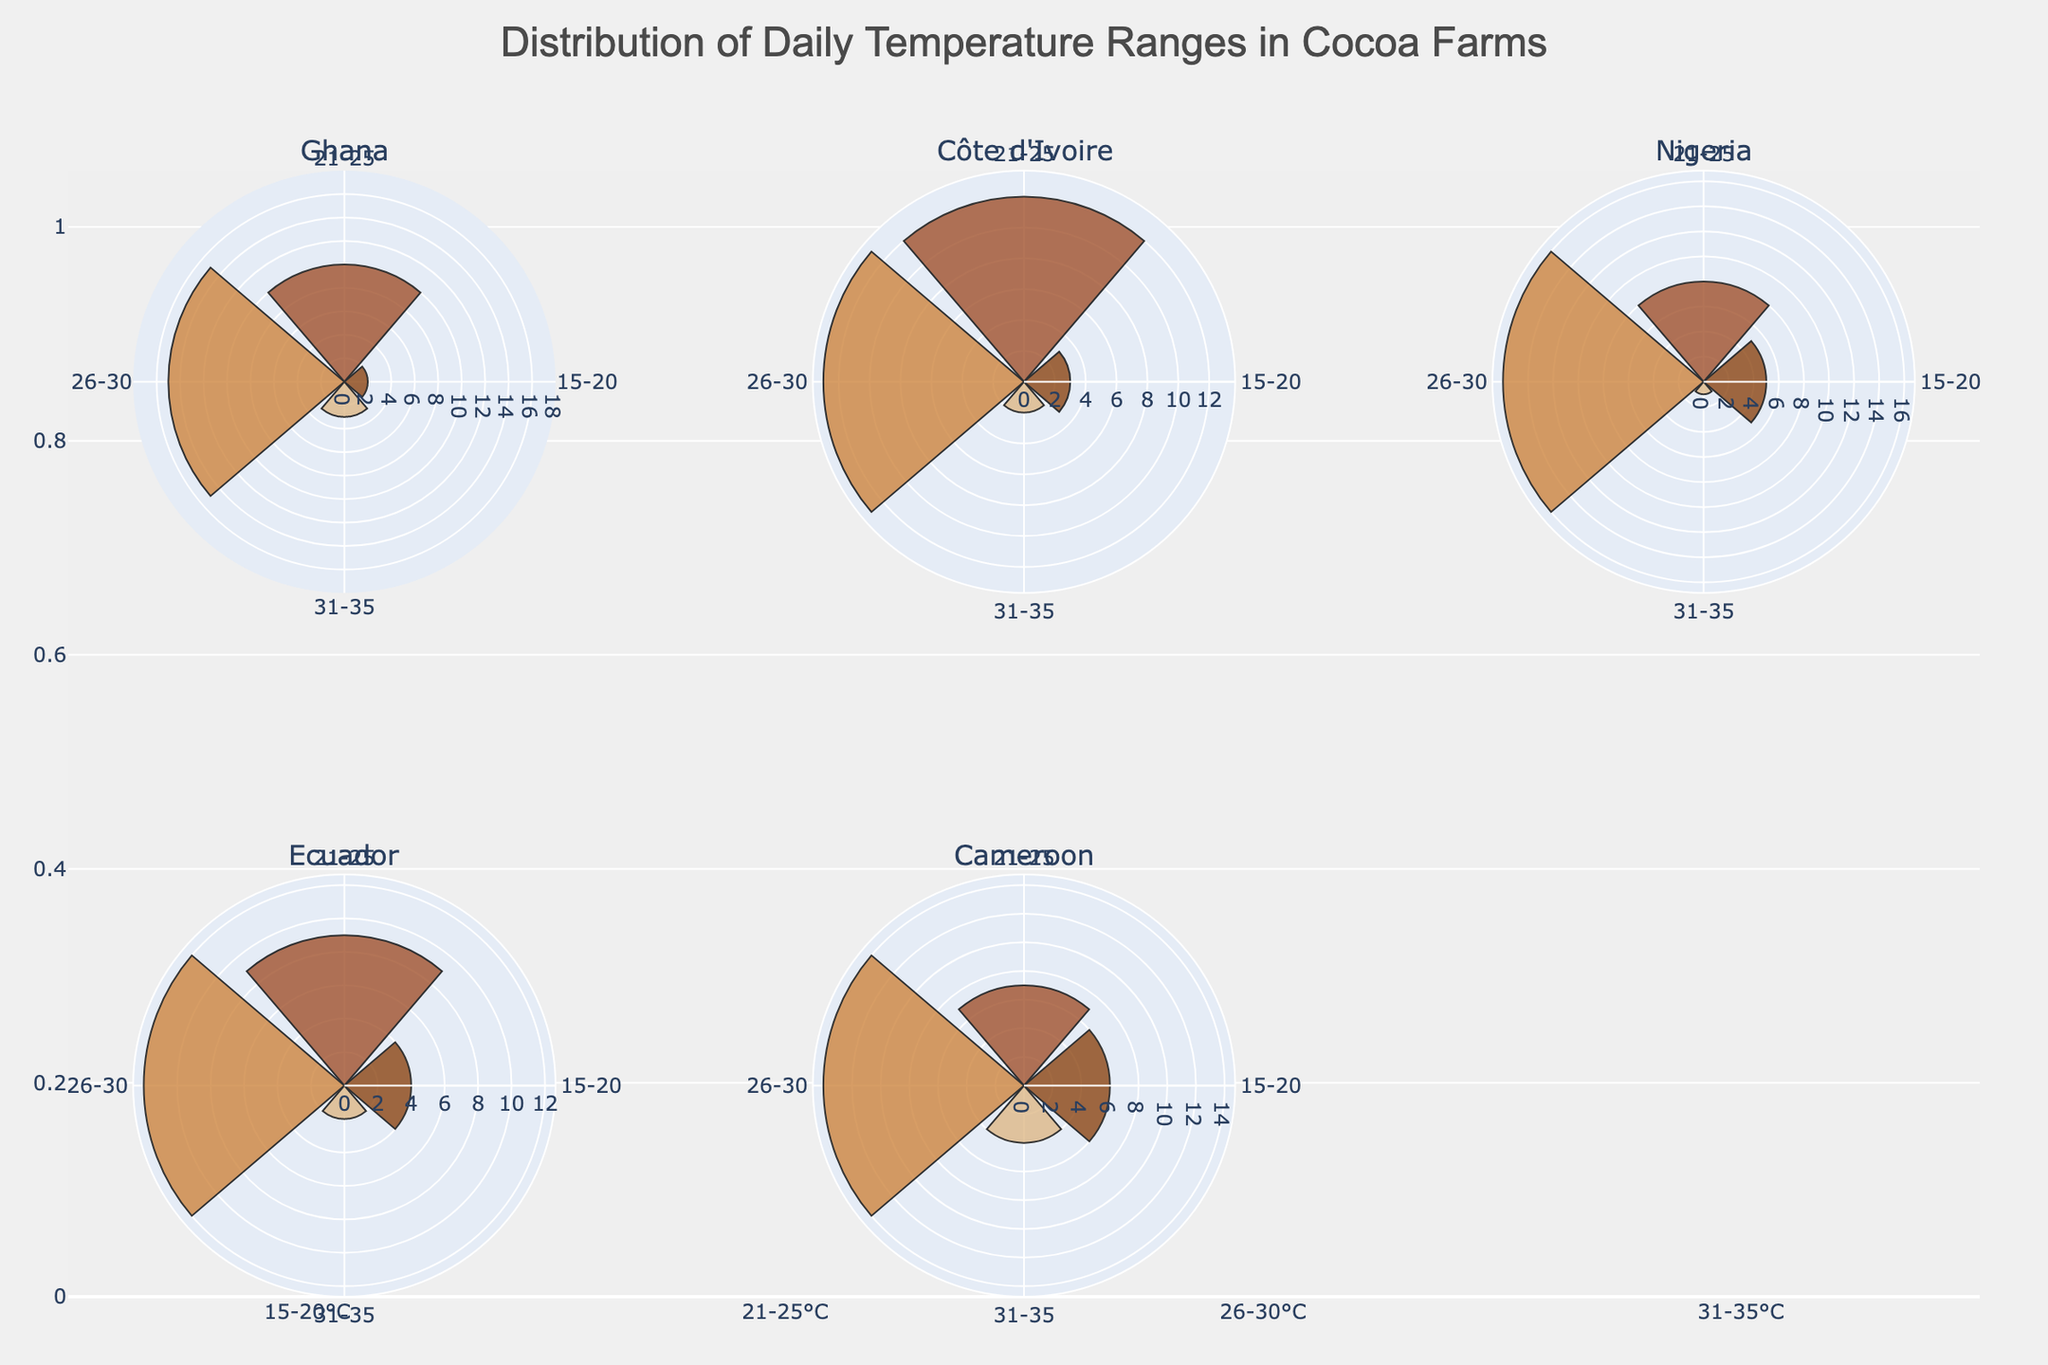What's the title of the plot? The title is located at the top center of the figure. It describes the overall content of the plot.
Answer: Distribution of Daily Temperature Ranges in Cocoa Farms What are the names of the regions shown in the subplots? The subplot titles represent the names of the regions and are located above each polar chart.
Answer: Ghana, Côte d'Ivoire, Nigeria, Ecuador, Cameroon How many temperature ranges are there for each region? The temperature ranges can be identified by looking at the different colored bars in each polar chart. Each region has 4 temperature ranges.
Answer: 4 Which region recorded the highest occurrences in a single temperature range, and what is the temperature range and number of occurrences? By comparing the lengths of the bars in all the subplots (polar charts), we see the longest bar among all the regions is in Ghana with the 26-30°C range having 15 occurrences.
Answer: Ghana, 26-30°C, 15 occurrences What is the most common temperature range for Cameroon in June? In the subplot for Cameroon, the largest bar indicates the most common temperature range. The longest bar is for the 26-30°C range.
Answer: 26-30°C Is there a region where the 31-35°C temperature range has more occurrences than the 15-20°C temperature range? By observing the lengths of the bars for these ranges in each region's subplot, the 31-35°C bars are shorter or equal to the 15-20°C bars in all regions.
Answer: No In which month and region do we see the widest spread of temperature range occurrences? For this, we need to see which region has a large difference between the occurrences of different temperature ranges. Ghana in January shows occurrences of 2, 10, 15, and 3, exhibiting a significant spread.
Answer: Ghana, January Which region and month had the least occurrences for the 31-35°C temperature range? By examining the lengths of the bars corresponding to the 31-35°C range, Nigeria in August has the smallest bar, indicating the least occurrences.
Answer: Nigeria, August What is the total number of temperature range occurrences recorded in Ecuador for December? Summing up the occurrences of all temperature ranges specifically for Ecuador, we have 4 (15-20°C) + 9 (21-25°C) + 12 (26-30°C) + 2 (31-35°C).
Answer: 27 occurrences 